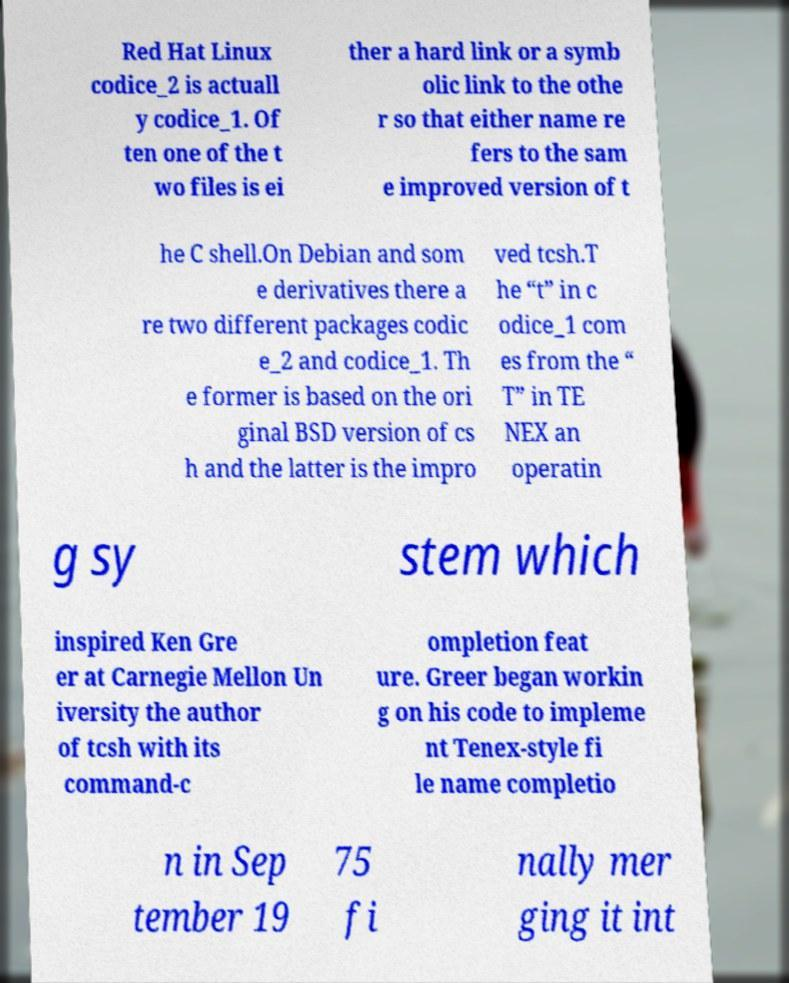There's text embedded in this image that I need extracted. Can you transcribe it verbatim? Red Hat Linux codice_2 is actuall y codice_1. Of ten one of the t wo files is ei ther a hard link or a symb olic link to the othe r so that either name re fers to the sam e improved version of t he C shell.On Debian and som e derivatives there a re two different packages codic e_2 and codice_1. Th e former is based on the ori ginal BSD version of cs h and the latter is the impro ved tcsh.T he “t” in c odice_1 com es from the “ T” in TE NEX an operatin g sy stem which inspired Ken Gre er at Carnegie Mellon Un iversity the author of tcsh with its command-c ompletion feat ure. Greer began workin g on his code to impleme nt Tenex-style fi le name completio n in Sep tember 19 75 fi nally mer ging it int 